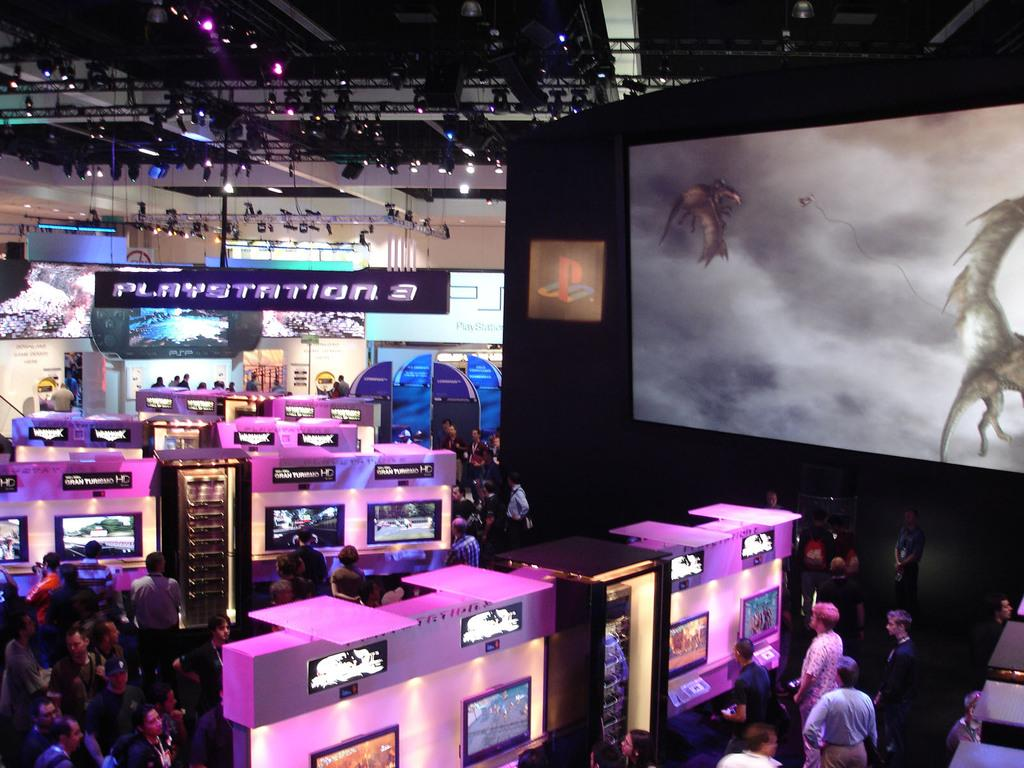What can be seen on the screens in the image? The specific content on the screens cannot be determined from the provided facts. What colors are used for the color boards in the image? The color boards in the image are white and pink. How many people are in the group visible in the image? The number of people in the group cannot be determined from the provided facts. What is the size of the large screen in the image? The size of the large screen cannot be determined from the provided facts. What type of decoration is present in the background of the image? Colorful borders are visible in the background of the image. What type of lighting is present in the background of the image? Lights are present in the background of the image. What type of card is being used to stir the jelly in the image? There is no card or jelly present in the image. What type of desk is visible in the image? There is no desk present in the image. 